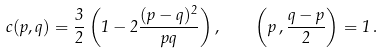Convert formula to latex. <formula><loc_0><loc_0><loc_500><loc_500>c ( p , q ) = \frac { 3 } { 2 } \left ( 1 - 2 \frac { ( p - q ) ^ { 2 } } { p q } \right ) , \quad \left ( p \, , \frac { q - p } 2 \right ) = 1 \, .</formula> 